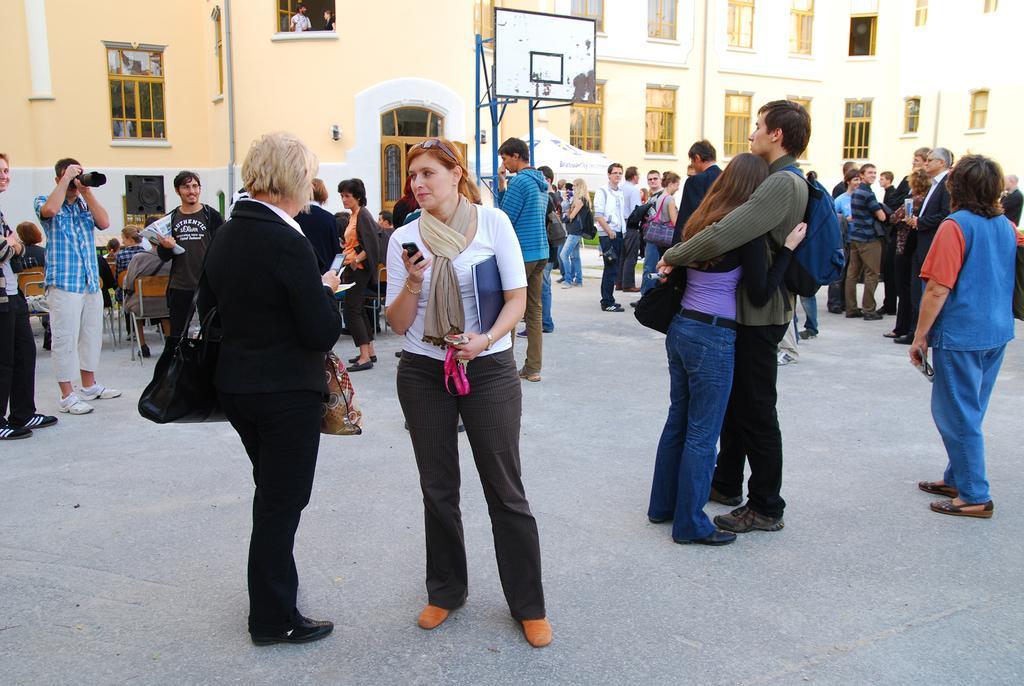Please provide a concise description of this image. In this picture we can see a group of people are standing on the floor, some people are sitting on chairs, board, bags, camera, building with windows and some objects. 